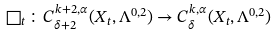Convert formula to latex. <formula><loc_0><loc_0><loc_500><loc_500>\square _ { t } \colon C ^ { k + 2 , \alpha } _ { \delta + 2 } ( X _ { t } , \Lambda ^ { 0 , 2 } ) \rightarrow C ^ { k , \alpha } _ { \delta } ( X _ { t } , \Lambda ^ { 0 , 2 } )</formula> 